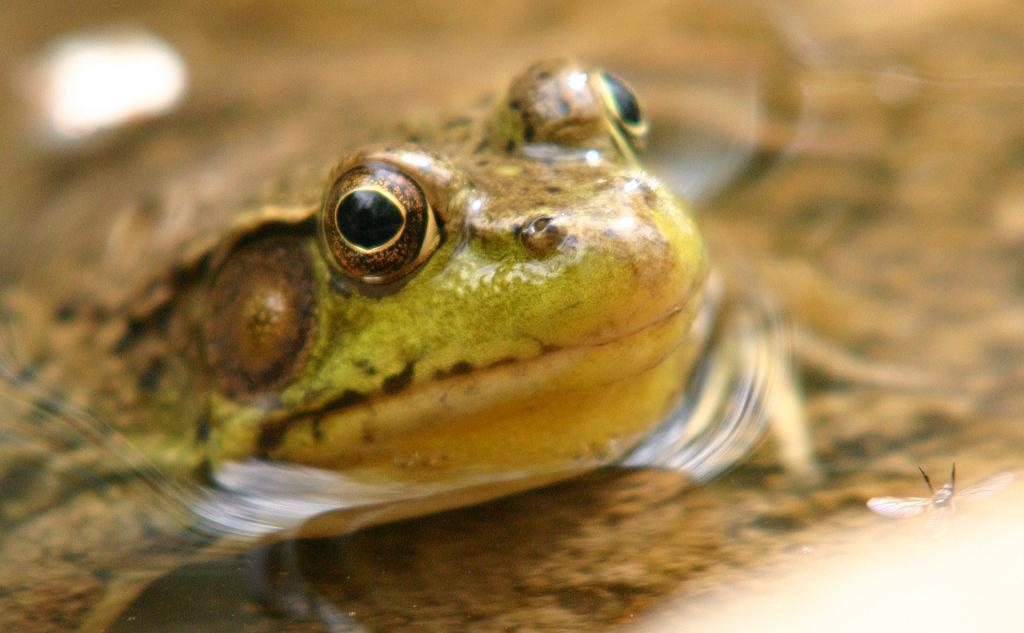What is the focus of the image? The image is zoomed in, so the focus is on a specific area. What can be seen in the right corner of the image? There is an insect in the right corner of the image. What is located in the left part of the image? There is a frog in the left part of the image. How is the frog positioned in the image? The frog appears to be standing on the ground. What is the appearance of the background in the image? The background of the image is blurred. What type of insurance policy is being discussed by the children in the image? There are no children present in the image, and no discussion about insurance policies can be observed. 